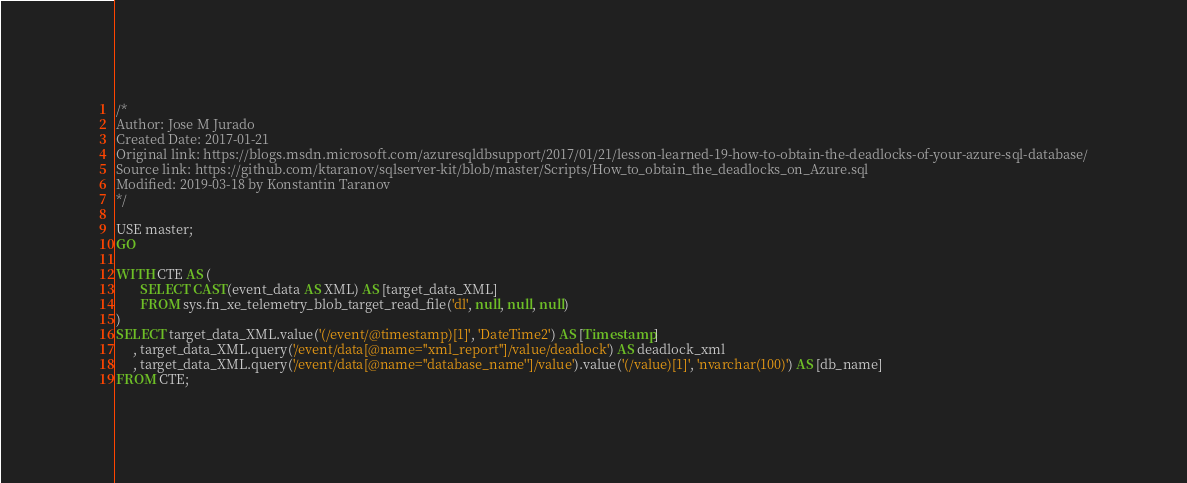<code> <loc_0><loc_0><loc_500><loc_500><_SQL_>/*
Author: Jose M Jurado
Created Date: 2017-01-21
Original link: https://blogs.msdn.microsoft.com/azuresqldbsupport/2017/01/21/lesson-learned-19-how-to-obtain-the-deadlocks-of-your-azure-sql-database/
Source link: https://github.com/ktaranov/sqlserver-kit/blob/master/Scripts/How_to_obtain_the_deadlocks_on_Azure.sql
Modified: 2019-03-18 by Konstantin Taranov
*/

USE master;
GO

WITH CTE AS (
       SELECT CAST(event_data AS XML) AS [target_data_XML]
       FROM sys.fn_xe_telemetry_blob_target_read_file('dl', null, null, null)
)
SELECT target_data_XML.value('(/event/@timestamp)[1]', 'DateTime2') AS [Timestamp]
     , target_data_XML.query('/event/data[@name=''xml_report'']/value/deadlock') AS deadlock_xml
     , target_data_XML.query('/event/data[@name=''database_name'']/value').value('(/value)[1]', 'nvarchar(100)') AS [db_name]
FROM CTE;
</code> 